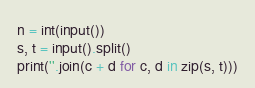<code> <loc_0><loc_0><loc_500><loc_500><_Python_>n = int(input())
s, t = input().split()
print(''.join(c + d for c, d in zip(s, t)))
</code> 